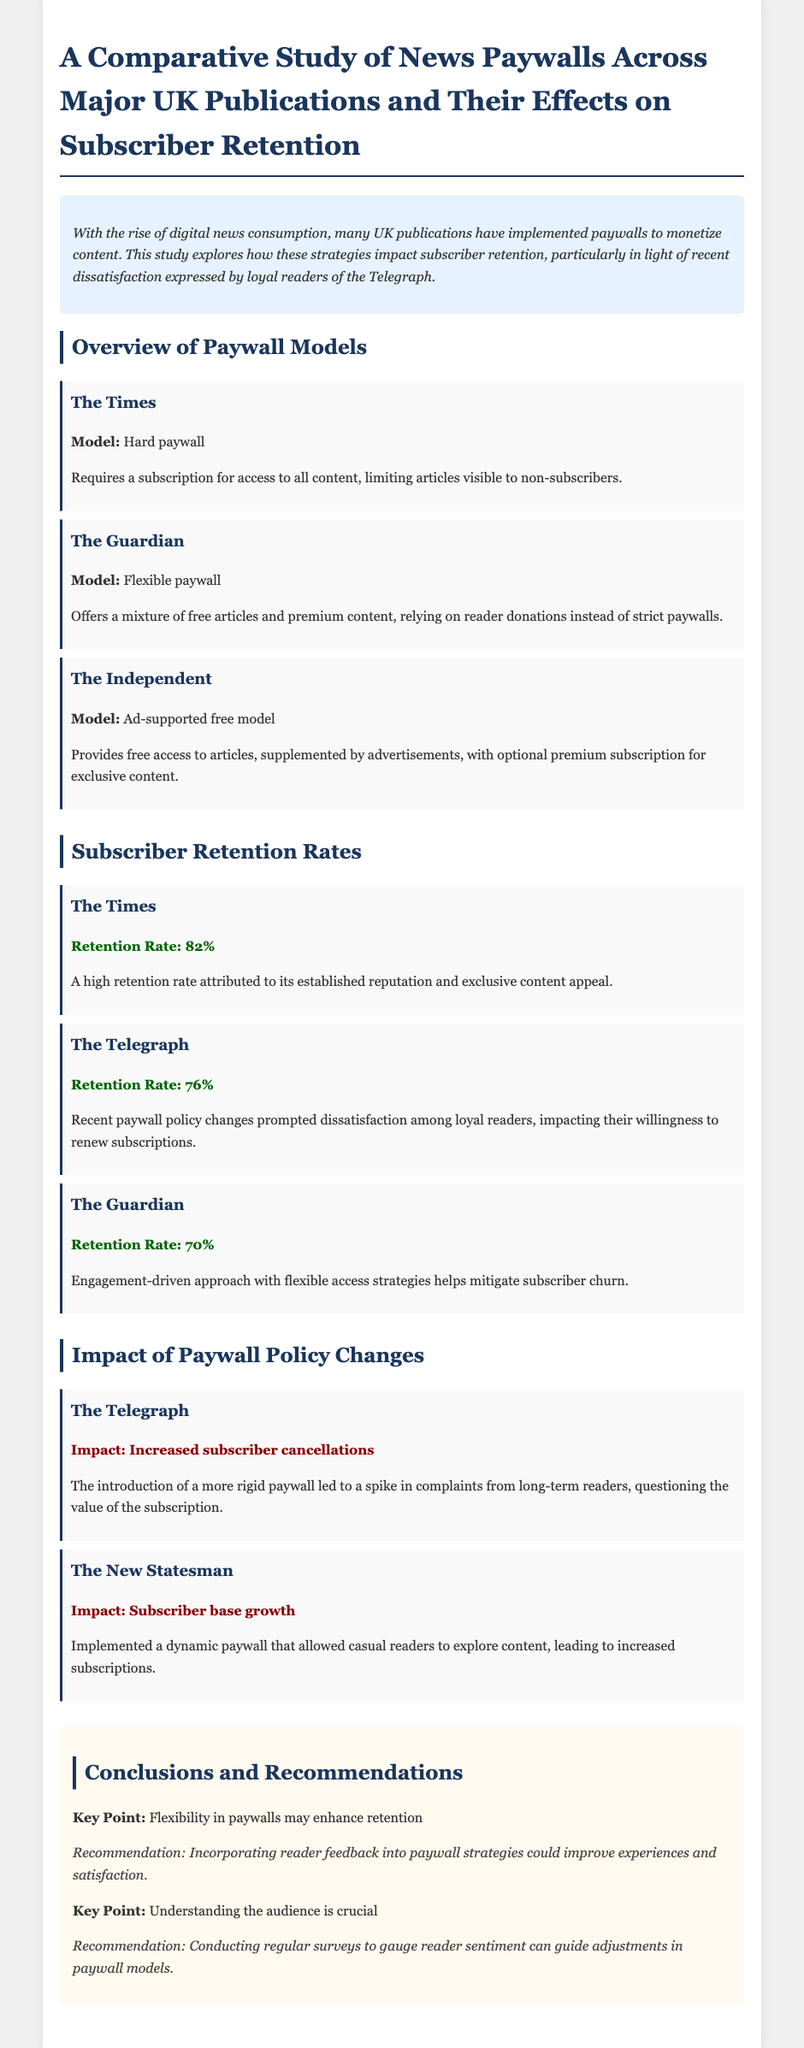What is the retention rate of The Times? The retention rate is a specific numerical value mentioned in the document under the Subscriber Retention Rates section.
Answer: 82% What type of paywall does The Guardian use? The type of paywall is defined in the Overview of Paywall Models section, describing how The Guardian operates.
Answer: Flexible paywall What effect did the new paywall policy have on The Telegraph? The effect is summarized in the Impact of Paywall Policy Changes section, highlighting subscriber response to policy changes.
Answer: Increased subscriber cancellations What is the retention rate of The Telegraph? The retention rate is listed in the Subscriber Retention Rates section as a specific percentage relevant to this publication.
Answer: 76% Which publication experienced subscriber base growth due to its paywall strategy? The information is found in the Impact of Paywall Policy Changes section, detailing subscriber reactions to different models.
Answer: The New Statesman What recommendation is made to improve paywall experiences? This recommendation is stated in the Conclusions and Recommendations section, specifically focused on reader engagement.
Answer: Incorporating reader feedback What is the retention rate of The Guardian? The retention rate is provided in the Subscriber Retention Rates section, detailing its performance in subscriber retention.
Answer: 70% What is the primary benefit mentioned for The Times' paywall model? The benefit is inferred from the Subscriber Retention Rates section, noting factors contributing to its retention rate.
Answer: Established reputation What key point is highlighted regarding flexibility in paywalls? This key point is noted in the Conclusions and Recommendations section, emphasizing its importance for subscriber retention.
Answer: Flexibility in paywalls may enhance retention 